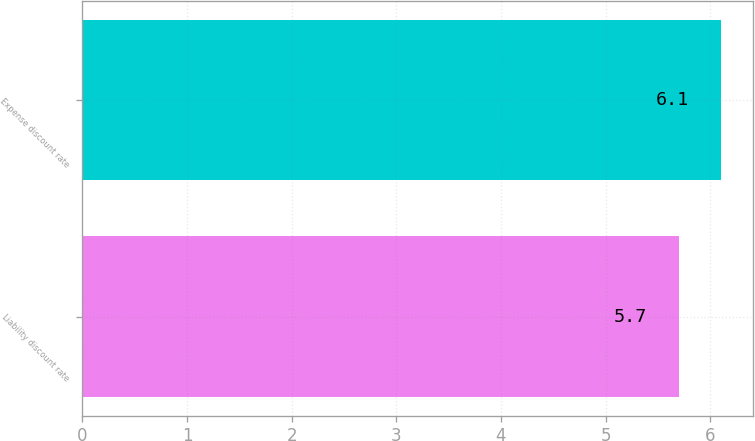Convert chart. <chart><loc_0><loc_0><loc_500><loc_500><bar_chart><fcel>Liability discount rate<fcel>Expense discount rate<nl><fcel>5.7<fcel>6.1<nl></chart> 